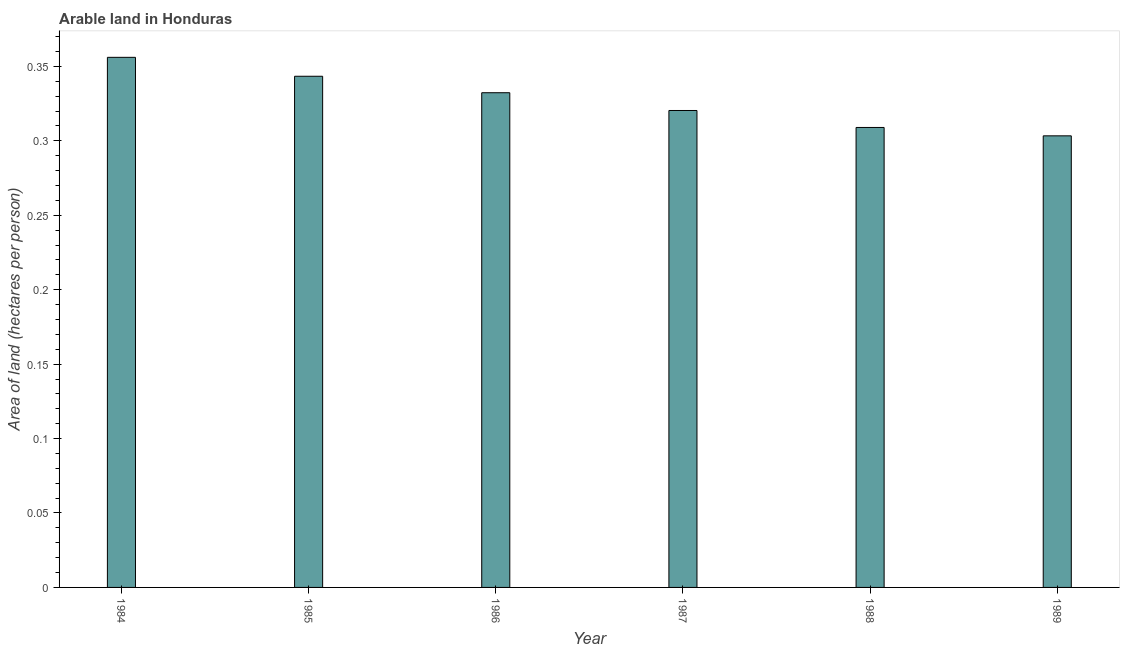What is the title of the graph?
Provide a short and direct response. Arable land in Honduras. What is the label or title of the Y-axis?
Ensure brevity in your answer.  Area of land (hectares per person). What is the area of arable land in 1986?
Your answer should be compact. 0.33. Across all years, what is the maximum area of arable land?
Provide a short and direct response. 0.36. Across all years, what is the minimum area of arable land?
Offer a terse response. 0.3. In which year was the area of arable land minimum?
Provide a succinct answer. 1989. What is the sum of the area of arable land?
Provide a succinct answer. 1.96. What is the difference between the area of arable land in 1986 and 1988?
Provide a short and direct response. 0.02. What is the average area of arable land per year?
Offer a very short reply. 0.33. What is the median area of arable land?
Provide a succinct answer. 0.33. In how many years, is the area of arable land greater than 0.32 hectares per person?
Provide a short and direct response. 4. What is the ratio of the area of arable land in 1987 to that in 1989?
Offer a terse response. 1.06. What is the difference between the highest and the second highest area of arable land?
Make the answer very short. 0.01. In how many years, is the area of arable land greater than the average area of arable land taken over all years?
Make the answer very short. 3. Are all the bars in the graph horizontal?
Your answer should be compact. No. How many years are there in the graph?
Keep it short and to the point. 6. What is the difference between two consecutive major ticks on the Y-axis?
Give a very brief answer. 0.05. What is the Area of land (hectares per person) of 1984?
Provide a short and direct response. 0.36. What is the Area of land (hectares per person) in 1985?
Give a very brief answer. 0.34. What is the Area of land (hectares per person) of 1986?
Your answer should be compact. 0.33. What is the Area of land (hectares per person) in 1987?
Provide a short and direct response. 0.32. What is the Area of land (hectares per person) in 1988?
Offer a terse response. 0.31. What is the Area of land (hectares per person) of 1989?
Provide a succinct answer. 0.3. What is the difference between the Area of land (hectares per person) in 1984 and 1985?
Provide a succinct answer. 0.01. What is the difference between the Area of land (hectares per person) in 1984 and 1986?
Keep it short and to the point. 0.02. What is the difference between the Area of land (hectares per person) in 1984 and 1987?
Offer a terse response. 0.04. What is the difference between the Area of land (hectares per person) in 1984 and 1988?
Ensure brevity in your answer.  0.05. What is the difference between the Area of land (hectares per person) in 1984 and 1989?
Provide a succinct answer. 0.05. What is the difference between the Area of land (hectares per person) in 1985 and 1986?
Make the answer very short. 0.01. What is the difference between the Area of land (hectares per person) in 1985 and 1987?
Ensure brevity in your answer.  0.02. What is the difference between the Area of land (hectares per person) in 1985 and 1988?
Your answer should be compact. 0.03. What is the difference between the Area of land (hectares per person) in 1985 and 1989?
Give a very brief answer. 0.04. What is the difference between the Area of land (hectares per person) in 1986 and 1987?
Offer a terse response. 0.01. What is the difference between the Area of land (hectares per person) in 1986 and 1988?
Your response must be concise. 0.02. What is the difference between the Area of land (hectares per person) in 1986 and 1989?
Offer a terse response. 0.03. What is the difference between the Area of land (hectares per person) in 1987 and 1988?
Your response must be concise. 0.01. What is the difference between the Area of land (hectares per person) in 1987 and 1989?
Your response must be concise. 0.02. What is the difference between the Area of land (hectares per person) in 1988 and 1989?
Make the answer very short. 0.01. What is the ratio of the Area of land (hectares per person) in 1984 to that in 1985?
Provide a succinct answer. 1.04. What is the ratio of the Area of land (hectares per person) in 1984 to that in 1986?
Offer a very short reply. 1.07. What is the ratio of the Area of land (hectares per person) in 1984 to that in 1987?
Give a very brief answer. 1.11. What is the ratio of the Area of land (hectares per person) in 1984 to that in 1988?
Provide a short and direct response. 1.15. What is the ratio of the Area of land (hectares per person) in 1984 to that in 1989?
Make the answer very short. 1.17. What is the ratio of the Area of land (hectares per person) in 1985 to that in 1986?
Your answer should be compact. 1.03. What is the ratio of the Area of land (hectares per person) in 1985 to that in 1987?
Offer a very short reply. 1.07. What is the ratio of the Area of land (hectares per person) in 1985 to that in 1988?
Ensure brevity in your answer.  1.11. What is the ratio of the Area of land (hectares per person) in 1985 to that in 1989?
Ensure brevity in your answer.  1.13. What is the ratio of the Area of land (hectares per person) in 1986 to that in 1988?
Provide a short and direct response. 1.08. What is the ratio of the Area of land (hectares per person) in 1986 to that in 1989?
Give a very brief answer. 1.09. What is the ratio of the Area of land (hectares per person) in 1987 to that in 1989?
Provide a succinct answer. 1.06. 